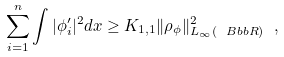Convert formula to latex. <formula><loc_0><loc_0><loc_500><loc_500>\sum _ { i = 1 } ^ { n } \int | \phi _ { i } ^ { \prime } | ^ { 2 } d x \geq K _ { 1 , 1 } \| \rho _ { \phi } \| ^ { 2 } _ { L _ { \infty } ( { \ B b b R } ) } \ ,</formula> 